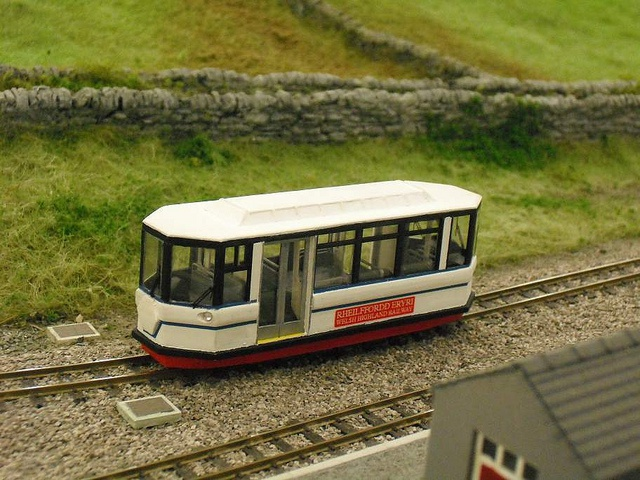Describe the objects in this image and their specific colors. I can see a train in olive, black, ivory, darkgreen, and tan tones in this image. 